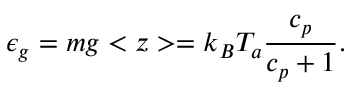Convert formula to latex. <formula><loc_0><loc_0><loc_500><loc_500>\epsilon _ { g } = m g < z > = k _ { B } T _ { a } { \frac { c _ { p } } { c _ { p } + 1 } } .</formula> 